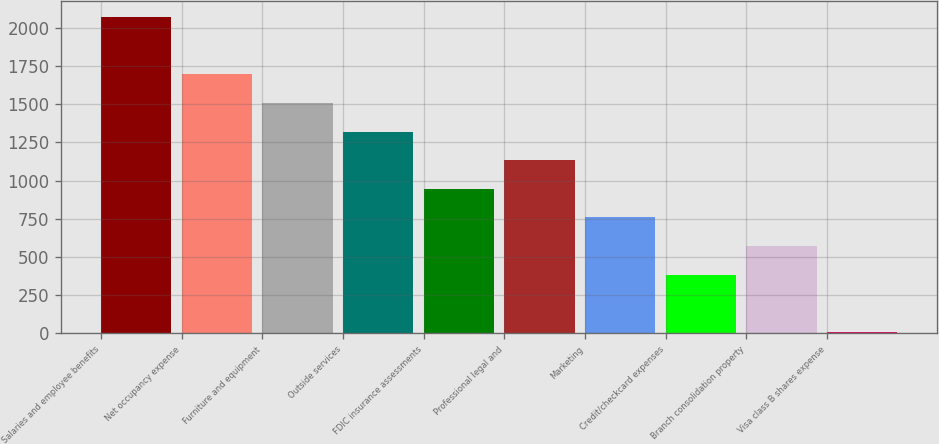Convert chart. <chart><loc_0><loc_0><loc_500><loc_500><bar_chart><fcel>Salaries and employee benefits<fcel>Net occupancy expense<fcel>Furniture and equipment<fcel>Outside services<fcel>FDIC insurance assessments<fcel>Professional legal and<fcel>Marketing<fcel>Credit/checkcard expenses<fcel>Branch consolidation property<fcel>Visa class B shares expense<nl><fcel>2070.4<fcel>1695.6<fcel>1508.2<fcel>1320.8<fcel>946<fcel>1133.4<fcel>758.6<fcel>383.8<fcel>571.2<fcel>9<nl></chart> 